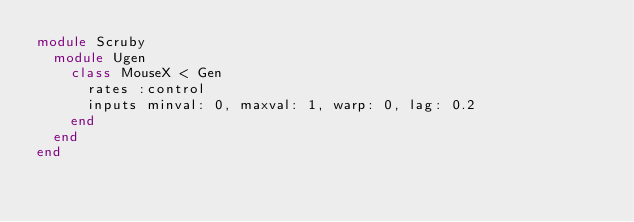Convert code to text. <code><loc_0><loc_0><loc_500><loc_500><_Ruby_>module Scruby
  module Ugen
    class MouseX < Gen
      rates :control
      inputs minval: 0, maxval: 1, warp: 0, lag: 0.2
    end
  end
end
</code> 